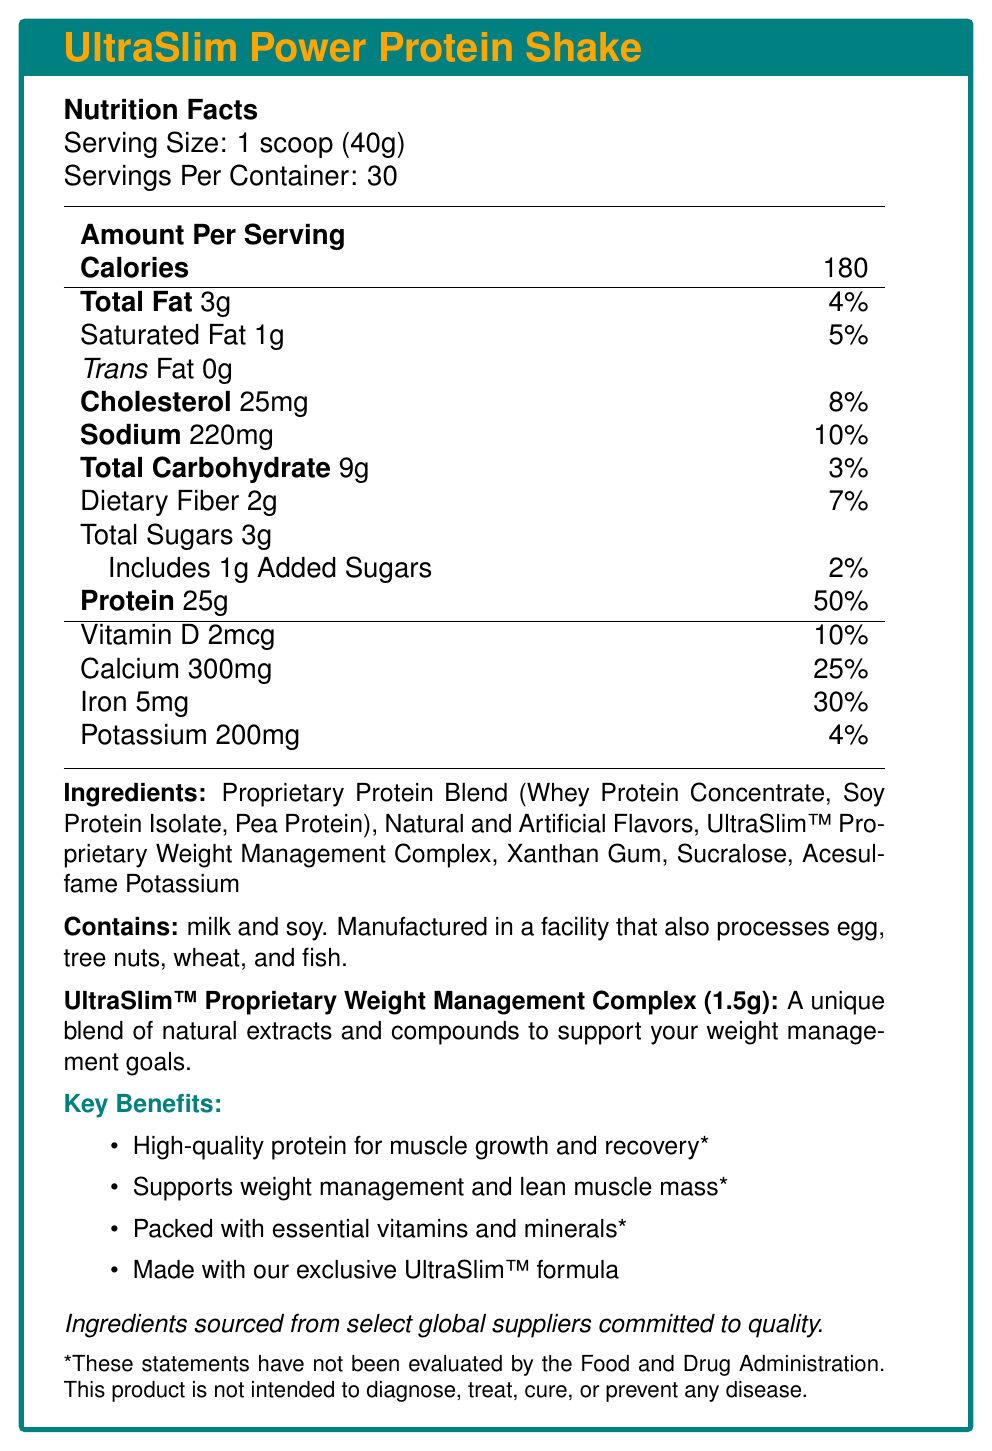what is the serving size of the UltraSlim Power Protein Shake? The serving size is listed under the Nutrition Facts section as "1 scoop (40g)".
Answer: 1 scoop (40g) how many calories are in one serving of the UltraSlim Power Protein Shake? The document specifies that there are 180 calories per serving.
Answer: 180 calories what is the amount of protein per serving and its daily value percentage? Under the Nutrition Facts, it states that each serving contains 25g of protein which corresponds to 50% of the daily value.
Answer: 25g, 50% how much sodium does one serving contain? The Nutrition Facts section lists 220mg of sodium per serving.
Answer: 220mg what is included in the proprietary protein blend? The ingredients list breaks down the proprietary protein blend into Whey Protein Concentrate, Soy Protein Isolate, and Pea Protein.
Answer: Whey Protein Concentrate, Soy Protein Isolate, Pea Protein which of the following ingredients is not listed in the UltraSlim Power Protein Shake? A. Xanthan Gum B. Stevia C. Sucralose D. Acesulfame Potassium The ingredient list includes Xanthan Gum, Sucralose, and Acesulfame Potassium, but not Stevia.
Answer: B. Stevia how many servings are contained in the package? The document specifies that there are 30 servings per container.
Answer: 30 servings the UltraSlim™ Proprietary Weight Management Complex is stated to weigh: The document details that the UltraSlim™ Proprietary Weight Management Complex weighs 1.5 grams.
Answer: 1.5g are the claims about the benefits of the product evaluated by the FDA? The disclaimer at the end of the document states that these claims have not been evaluated by the FDA.
Answer: No does the product contain any allergens? The document states that the product contains milk and soy, and is manufactured in a facility that processes egg, tree nuts, wheat, and fish.
Answer: Yes what are the potential health benefits mentioned for the UltraSlim Power Protein Shake? A. Muscle growth and recovery B. Improved eyesight C. Lean muscle mass support D. Weight management The document mentions potential benefits such as muscle growth and recovery, lean muscle mass support, and weight management, but not improved eyesight.
Answer: B can the sourcing locations of the ingredients be determined from the document? The sourcing statement only states that the ingredients are sourced from "select global suppliers committed to quality", but does not specify locations.
Answer: No which ingredient is used as a thickening agent in the UltraSlim Power Protein Shake? Xanthan Gum is listed in the ingredients, commonly used as a thickening agent.
Answer: Xanthan Gum what disclaimers are included regarding the product? The document includes a disclaimer at the end stating that these statements have not been evaluated by the FDA and the product is not intended to diagnose, treat, cure, or prevent any disease.
Answer: "*These statements have not been evaluated by the Food and Drug Administration. This product is not intended to diagnose, treat, cure, or prevent any disease." is the document primarily focused on the nutrition information of the product? The document provides detailed nutrition facts, ingredients, and allergen information for the UltraSlim Power Protein Shake, indicating a focus on its nutritional content.
Answer: True summarize the main points in the UltraSlim Power Protein Shake document. The document aims to provide comprehensive information on the nutrition facts, ingredients, and claimed benefits of the UltraSlim Power Protein Shake. It also includes disclaimers about the evaluation of the claims and allergen information.
Answer: The UltraSlim Power Protein Shake document includes information about the serving size and number of servings per container. It lists detailed nutrition facts such as calories, fats, cholesterol, sodium, carbohydrates, sugars, and protein. The main ingredients include a proprietary protein blend and a weight management complex. Several health benefits are claimed, although they are not evaluated by the FDA. The product contains allergens like milk and soy and is made from ingredients sourced from select global suppliers. 